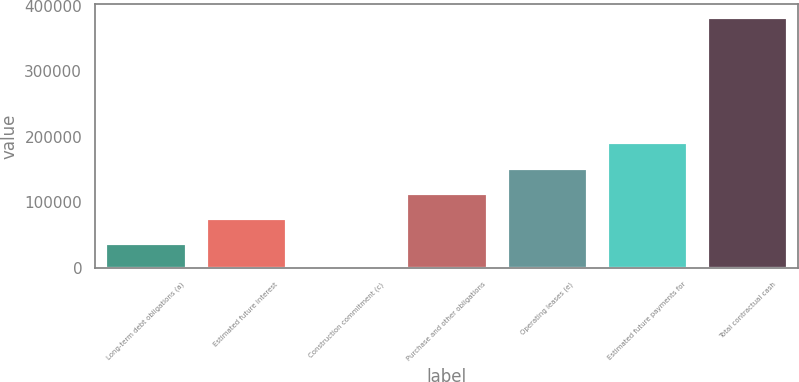<chart> <loc_0><loc_0><loc_500><loc_500><bar_chart><fcel>Long-term debt obligations (a)<fcel>Estimated future interest<fcel>Construction commitment (c)<fcel>Purchase and other obligations<fcel>Operating leases (e)<fcel>Estimated future payments for<fcel>Total contractual cash<nl><fcel>38336<fcel>76669.8<fcel>2.25<fcel>115004<fcel>153337<fcel>191671<fcel>383340<nl></chart> 